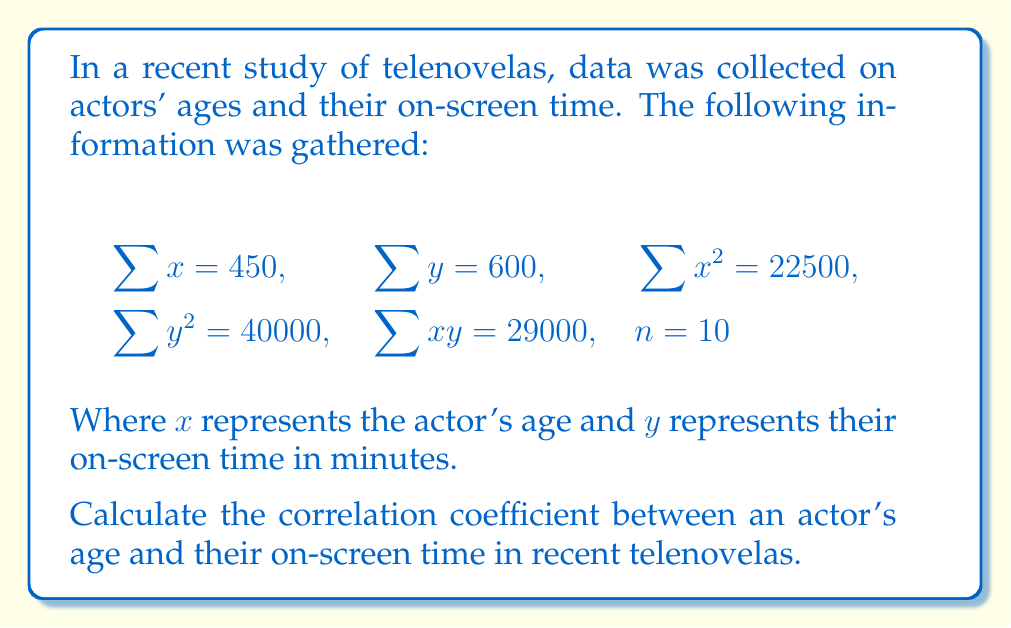Teach me how to tackle this problem. To find the correlation coefficient, we'll use the formula:

$$r = \frac{n\sum xy - \sum x \sum y}{\sqrt{[n\sum x^2 - (\sum x)^2][n\sum y^2 - (\sum y)^2]}}$$

Let's calculate each part step by step:

1) $n\sum xy = 10 \cdot 29000 = 290000$
2) $\sum x \sum y = 450 \cdot 600 = 270000$
3) $n\sum x^2 = 10 \cdot 22500 = 225000$
4) $(\sum x)^2 = 450^2 = 202500$
5) $n\sum y^2 = 10 \cdot 40000 = 400000$
6) $(\sum y)^2 = 600^2 = 360000$

Now, let's substitute these values into the formula:

$$r = \frac{290000 - 270000}{\sqrt{(225000 - 202500)(400000 - 360000)}}$$

$$r = \frac{20000}{\sqrt{(22500)(40000)}}$$

$$r = \frac{20000}{\sqrt{900000000}}$$

$$r = \frac{20000}{30000}$$

$$r = \frac{2}{3} \approx 0.6667$$
Answer: $r \approx 0.6667$ 